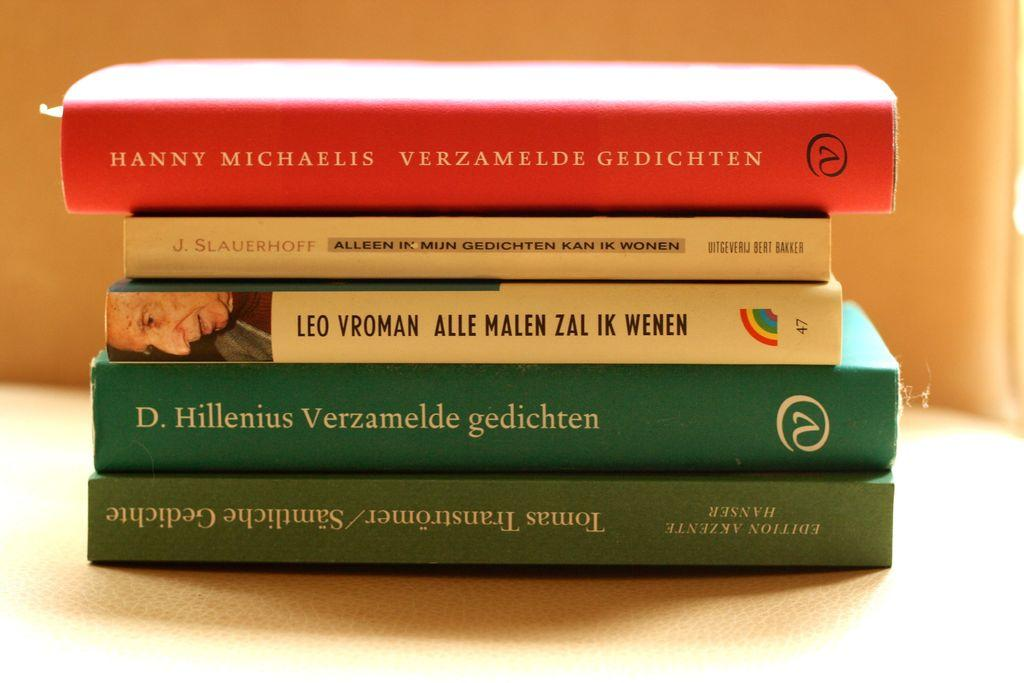<image>
Create a compact narrative representing the image presented. The stack of books includes "Verzamelde Gedichten", "Alleen In Mijn Gedichten Kan ik Wonen", and "Alle Malen Zal ik Wenen". 